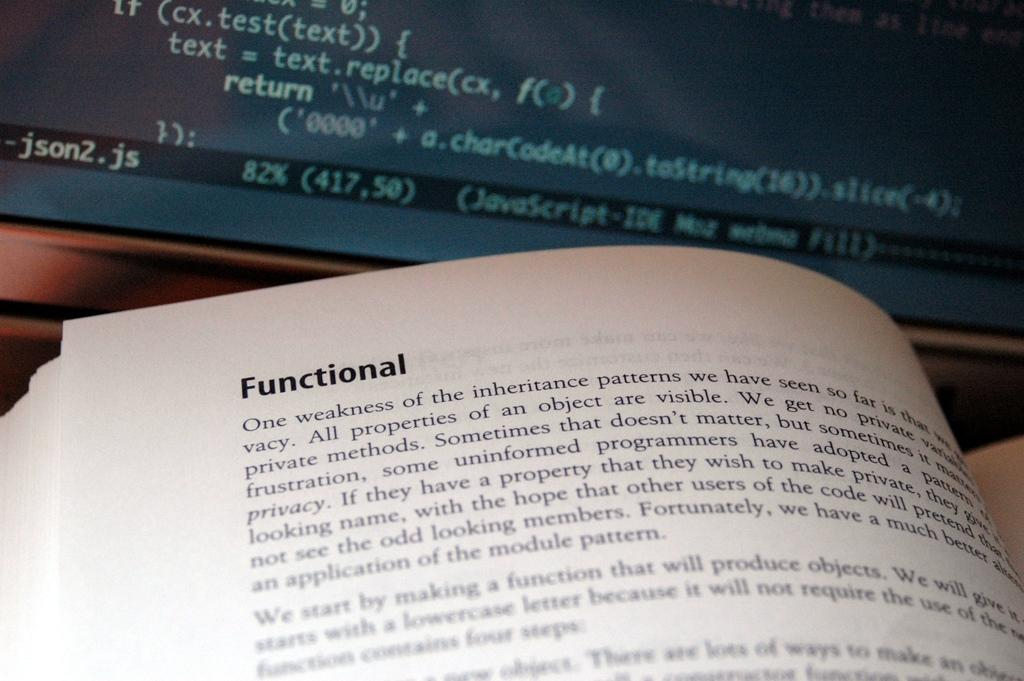<image>
Provide a brief description of the given image. A book is opened to a page with Functional in the upper left corner. 